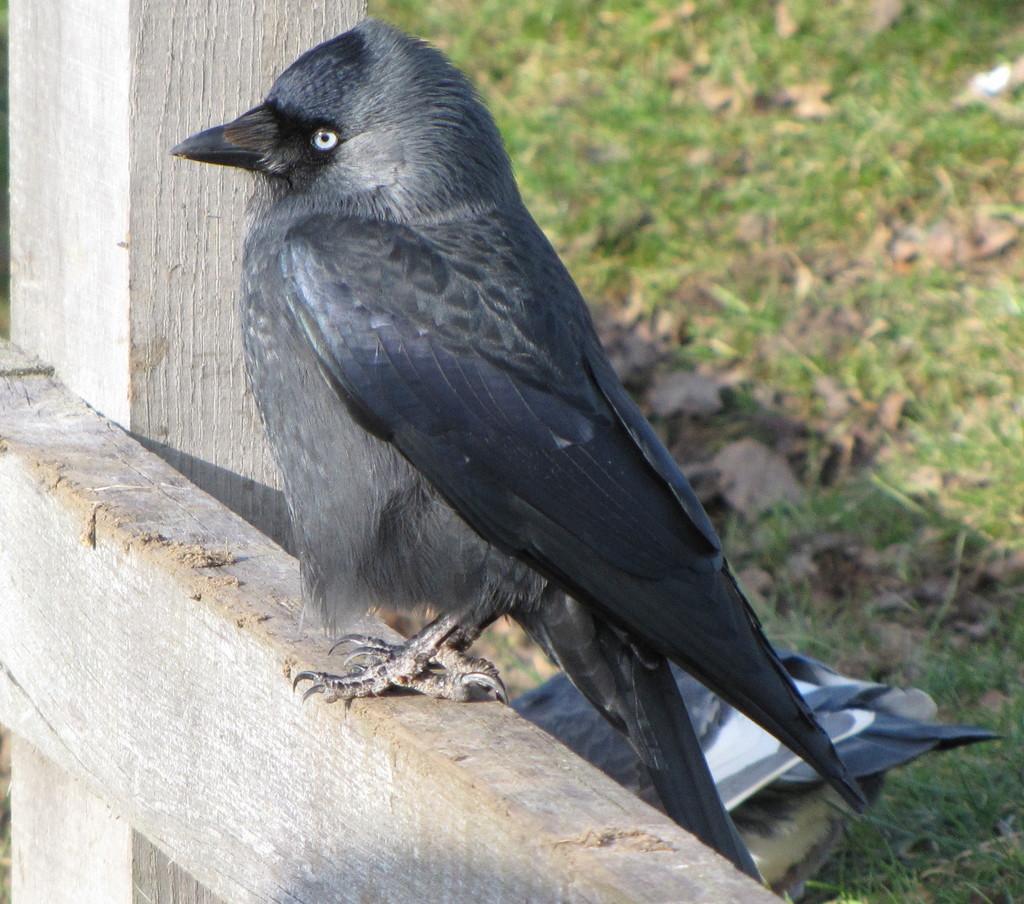Please provide a concise description of this image. This image consists of a bird in black color. And we can see the wooden sticks. On the right, there is green grass along with dried leaves. 